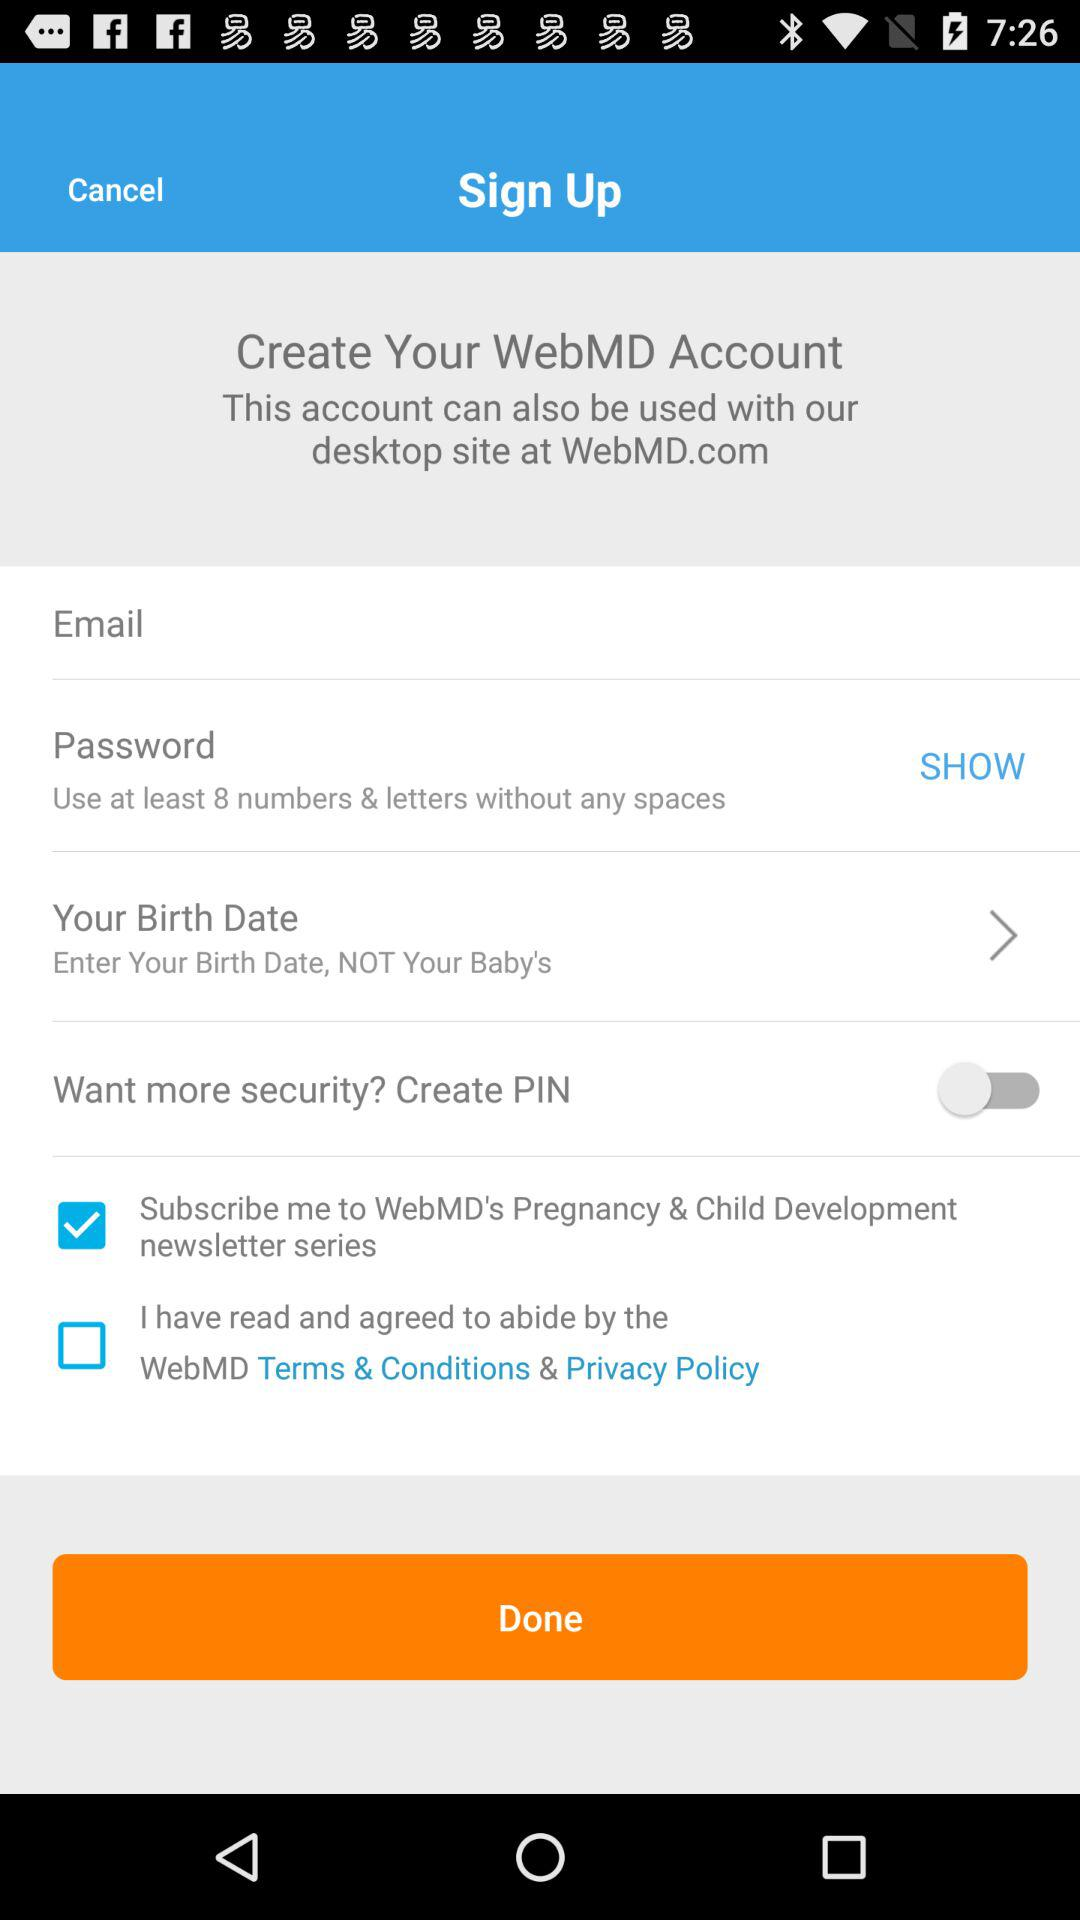How many items are not required to be filled out to create an account?
Answer the question using a single word or phrase. 2 